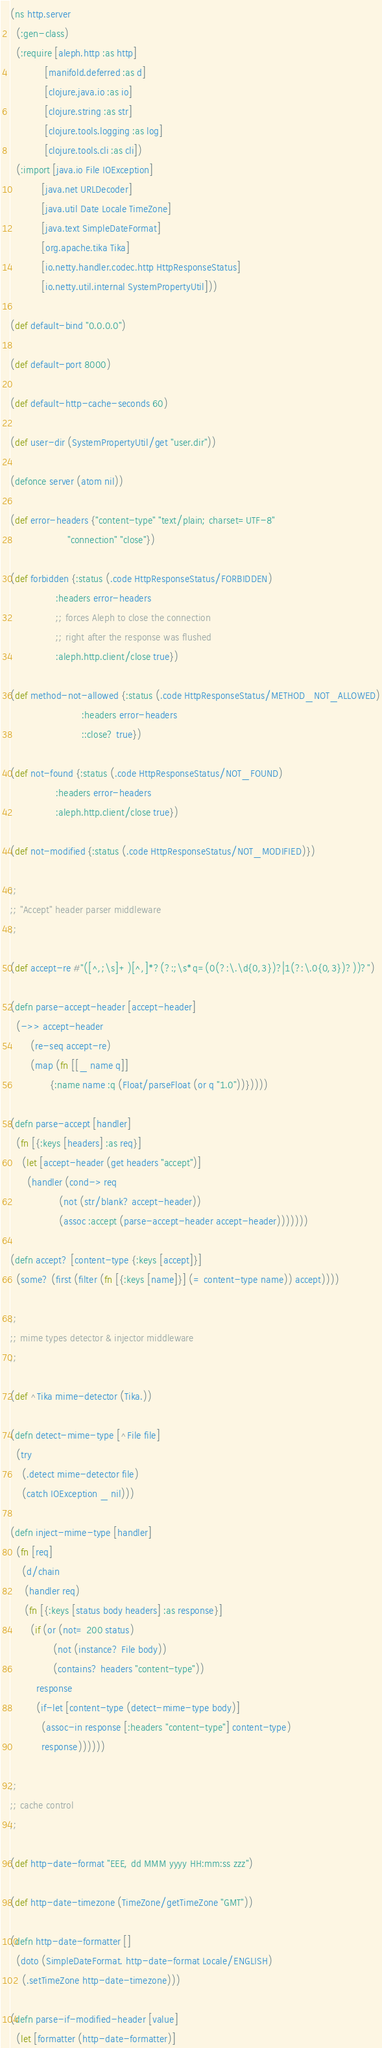<code> <loc_0><loc_0><loc_500><loc_500><_Clojure_>(ns http.server
  (:gen-class)
  (:require [aleph.http :as http]
            [manifold.deferred :as d]
            [clojure.java.io :as io]
            [clojure.string :as str]
            [clojure.tools.logging :as log]
            [clojure.tools.cli :as cli])
  (:import [java.io File IOException]
           [java.net URLDecoder]
           [java.util Date Locale TimeZone]
           [java.text SimpleDateFormat]
           [org.apache.tika Tika]
           [io.netty.handler.codec.http HttpResponseStatus]
           [io.netty.util.internal SystemPropertyUtil]))

(def default-bind "0.0.0.0")

(def default-port 8000)

(def default-http-cache-seconds 60)

(def user-dir (SystemPropertyUtil/get "user.dir"))

(defonce server (atom nil))

(def error-headers {"content-type" "text/plain; charset=UTF-8"
                    "connection" "close"})

(def forbidden {:status (.code HttpResponseStatus/FORBIDDEN)
                :headers error-headers
                ;; forces Aleph to close the connection
                ;; right after the response was flushed
                :aleph.http.client/close true})

(def method-not-allowed {:status (.code HttpResponseStatus/METHOD_NOT_ALLOWED)
                         :headers error-headers
                         ::close? true})

(def not-found {:status (.code HttpResponseStatus/NOT_FOUND)
                :headers error-headers
                :aleph.http.client/close true})

(def not-modified {:status (.code HttpResponseStatus/NOT_MODIFIED)})

;;
;; "Accept" header parser middleware
;;

(def accept-re #"([^,;\s]+)[^,]*?(?:;\s*q=(0(?:\.\d{0,3})?|1(?:\.0{0,3})?))?")

(defn parse-accept-header [accept-header]
  (->> accept-header
       (re-seq accept-re)
       (map (fn [[_ name q]]
              {:name name :q (Float/parseFloat (or q "1.0"))}))))

(defn parse-accept [handler]
  (fn [{:keys [headers] :as req}]
    (let [accept-header (get headers "accept")]
      (handler (cond-> req
                 (not (str/blank? accept-header))
                 (assoc :accept (parse-accept-header accept-header)))))))

(defn accept? [content-type {:keys [accept]}]
  (some? (first (filter (fn [{:keys [name]}] (= content-type name)) accept))))

;;
;; mime types detector & injector middleware
;;

(def ^Tika mime-detector (Tika.))

(defn detect-mime-type [^File file]
  (try
    (.detect mime-detector file)
    (catch IOException _ nil)))

(defn inject-mime-type [handler]
  (fn [req]
    (d/chain
     (handler req)
     (fn [{:keys [status body headers] :as response}]
       (if (or (not= 200 status)
               (not (instance? File body))
               (contains? headers "content-type"))
         response
         (if-let [content-type (detect-mime-type body)]
           (assoc-in response [:headers "content-type"] content-type)
           response))))))

;;
;; cache control
;;

(def http-date-format "EEE, dd MMM yyyy HH:mm:ss zzz")

(def http-date-timezone (TimeZone/getTimeZone "GMT"))

(defn http-date-formatter []
  (doto (SimpleDateFormat. http-date-format Locale/ENGLISH)
    (.setTimeZone http-date-timezone)))

(defn parse-if-modified-header [value]
  (let [formatter (http-date-formatter)]</code> 